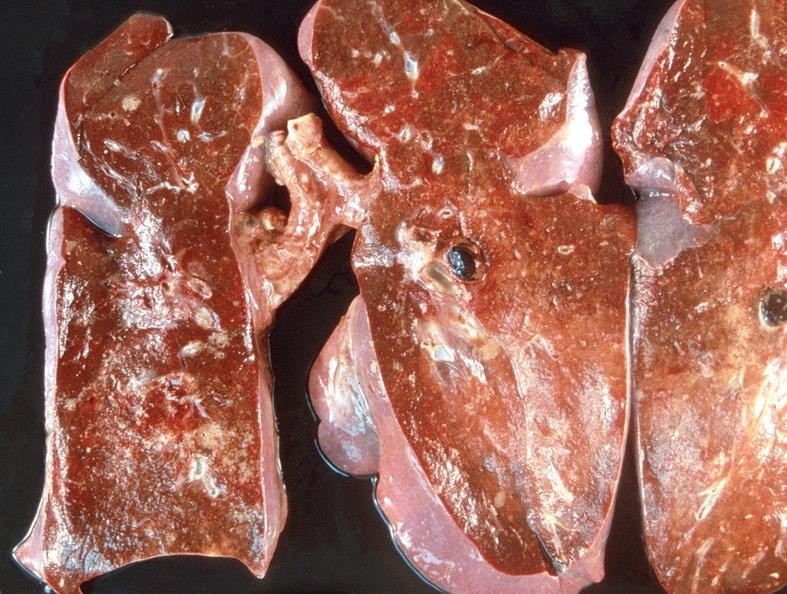what does this image show?
Answer the question using a single word or phrase. Pulmonary thromboemboli 